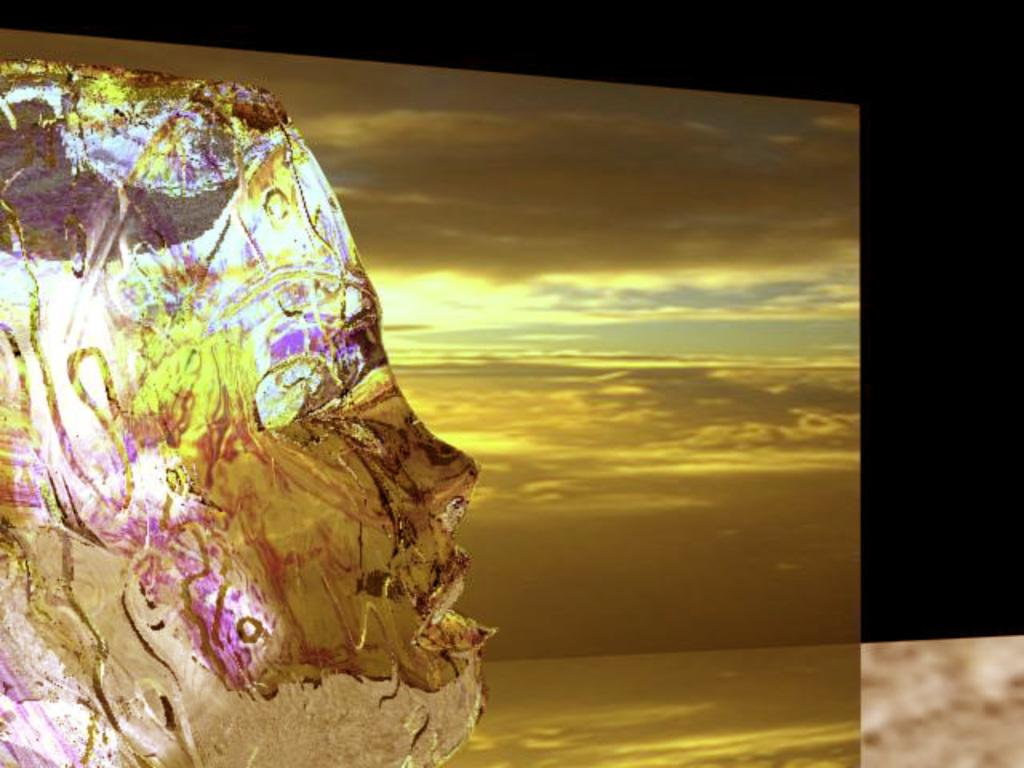What is the main subject of the image? There is a sculpture in the image. What can be seen in the background of the image? There is a golden sheet and a black sheet in the background of the image. What type of business is being conducted on the sidewalk in the image? There is no sidewalk or business activity present in the image; it features a sculpture and background sheets. 